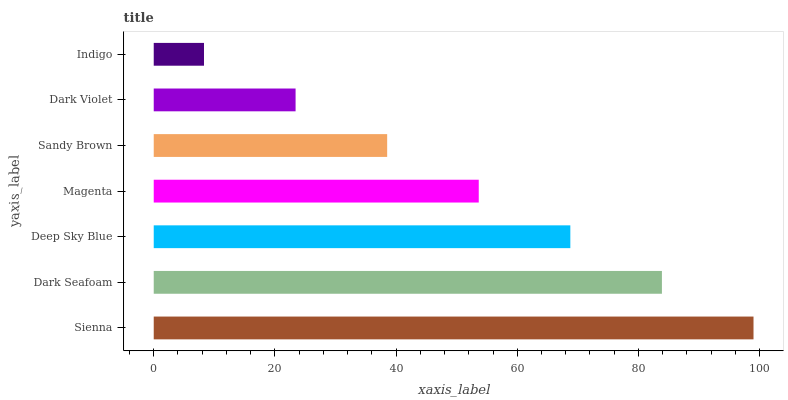Is Indigo the minimum?
Answer yes or no. Yes. Is Sienna the maximum?
Answer yes or no. Yes. Is Dark Seafoam the minimum?
Answer yes or no. No. Is Dark Seafoam the maximum?
Answer yes or no. No. Is Sienna greater than Dark Seafoam?
Answer yes or no. Yes. Is Dark Seafoam less than Sienna?
Answer yes or no. Yes. Is Dark Seafoam greater than Sienna?
Answer yes or no. No. Is Sienna less than Dark Seafoam?
Answer yes or no. No. Is Magenta the high median?
Answer yes or no. Yes. Is Magenta the low median?
Answer yes or no. Yes. Is Dark Seafoam the high median?
Answer yes or no. No. Is Dark Seafoam the low median?
Answer yes or no. No. 